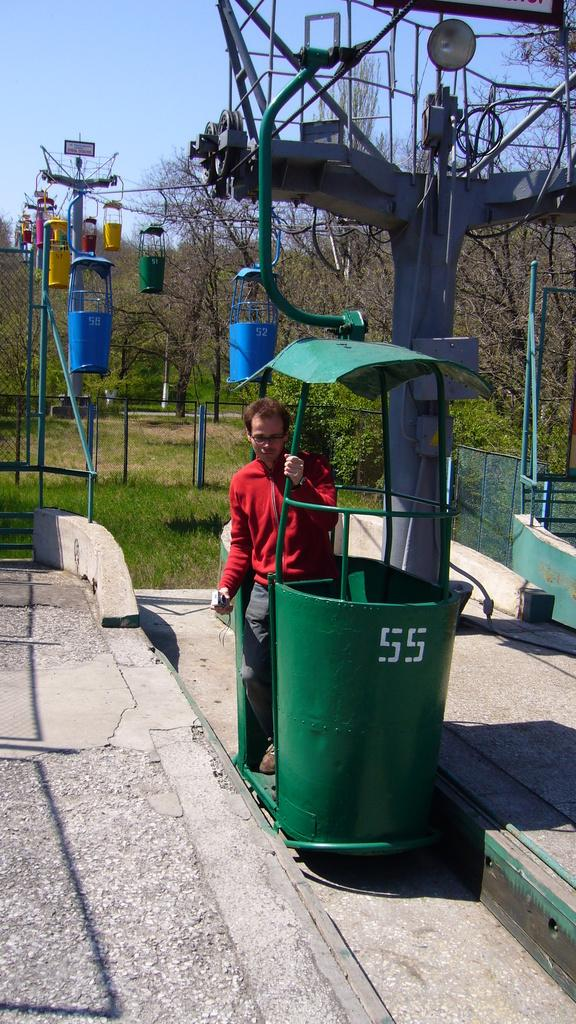<image>
Provide a brief description of the given image. The number "55" is on a trash can. 